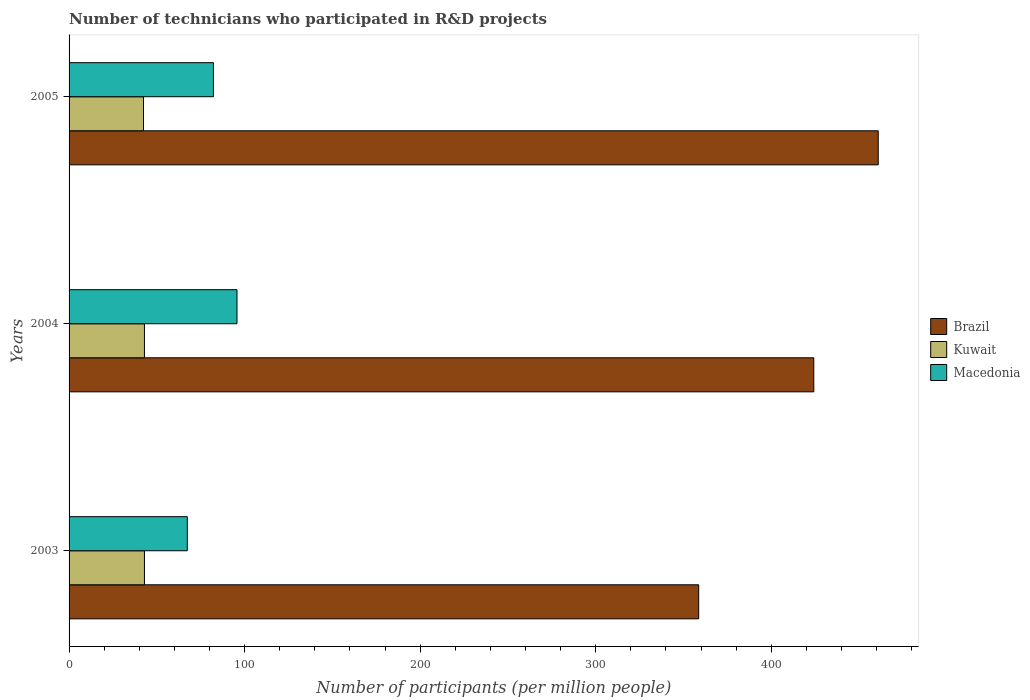How many different coloured bars are there?
Provide a short and direct response. 3. How many groups of bars are there?
Keep it short and to the point. 3. Are the number of bars per tick equal to the number of legend labels?
Offer a terse response. Yes. Are the number of bars on each tick of the Y-axis equal?
Provide a succinct answer. Yes. How many bars are there on the 1st tick from the bottom?
Make the answer very short. 3. What is the number of technicians who participated in R&D projects in Macedonia in 2005?
Your answer should be compact. 82.24. Across all years, what is the maximum number of technicians who participated in R&D projects in Macedonia?
Provide a short and direct response. 95.66. Across all years, what is the minimum number of technicians who participated in R&D projects in Kuwait?
Make the answer very short. 42.41. What is the total number of technicians who participated in R&D projects in Brazil in the graph?
Provide a succinct answer. 1243.77. What is the difference between the number of technicians who participated in R&D projects in Macedonia in 2003 and that in 2004?
Give a very brief answer. -28.31. What is the difference between the number of technicians who participated in R&D projects in Brazil in 2004 and the number of technicians who participated in R&D projects in Macedonia in 2005?
Offer a terse response. 341.98. What is the average number of technicians who participated in R&D projects in Macedonia per year?
Give a very brief answer. 81.75. In the year 2003, what is the difference between the number of technicians who participated in R&D projects in Kuwait and number of technicians who participated in R&D projects in Brazil?
Your response must be concise. -315.71. In how many years, is the number of technicians who participated in R&D projects in Kuwait greater than 200 ?
Make the answer very short. 0. What is the ratio of the number of technicians who participated in R&D projects in Kuwait in 2003 to that in 2005?
Ensure brevity in your answer.  1.01. What is the difference between the highest and the second highest number of technicians who participated in R&D projects in Kuwait?
Ensure brevity in your answer.  0.01. What is the difference between the highest and the lowest number of technicians who participated in R&D projects in Kuwait?
Your response must be concise. 0.53. In how many years, is the number of technicians who participated in R&D projects in Brazil greater than the average number of technicians who participated in R&D projects in Brazil taken over all years?
Your answer should be very brief. 2. What does the 1st bar from the top in 2005 represents?
Offer a very short reply. Macedonia. What does the 2nd bar from the bottom in 2003 represents?
Give a very brief answer. Kuwait. What is the difference between two consecutive major ticks on the X-axis?
Make the answer very short. 100. Are the values on the major ticks of X-axis written in scientific E-notation?
Offer a terse response. No. Does the graph contain any zero values?
Your response must be concise. No. Where does the legend appear in the graph?
Ensure brevity in your answer.  Center right. What is the title of the graph?
Offer a very short reply. Number of technicians who participated in R&D projects. What is the label or title of the X-axis?
Your response must be concise. Number of participants (per million people). What is the label or title of the Y-axis?
Offer a terse response. Years. What is the Number of participants (per million people) in Brazil in 2003?
Offer a very short reply. 358.64. What is the Number of participants (per million people) in Kuwait in 2003?
Give a very brief answer. 42.94. What is the Number of participants (per million people) of Macedonia in 2003?
Provide a succinct answer. 67.36. What is the Number of participants (per million people) of Brazil in 2004?
Offer a very short reply. 424.21. What is the Number of participants (per million people) of Kuwait in 2004?
Offer a very short reply. 42.93. What is the Number of participants (per million people) in Macedonia in 2004?
Your response must be concise. 95.66. What is the Number of participants (per million people) of Brazil in 2005?
Keep it short and to the point. 460.92. What is the Number of participants (per million people) of Kuwait in 2005?
Provide a short and direct response. 42.41. What is the Number of participants (per million people) of Macedonia in 2005?
Offer a very short reply. 82.24. Across all years, what is the maximum Number of participants (per million people) of Brazil?
Make the answer very short. 460.92. Across all years, what is the maximum Number of participants (per million people) in Kuwait?
Keep it short and to the point. 42.94. Across all years, what is the maximum Number of participants (per million people) in Macedonia?
Provide a succinct answer. 95.66. Across all years, what is the minimum Number of participants (per million people) of Brazil?
Make the answer very short. 358.64. Across all years, what is the minimum Number of participants (per million people) of Kuwait?
Keep it short and to the point. 42.41. Across all years, what is the minimum Number of participants (per million people) in Macedonia?
Your answer should be compact. 67.36. What is the total Number of participants (per million people) of Brazil in the graph?
Offer a very short reply. 1243.77. What is the total Number of participants (per million people) in Kuwait in the graph?
Keep it short and to the point. 128.28. What is the total Number of participants (per million people) in Macedonia in the graph?
Ensure brevity in your answer.  245.25. What is the difference between the Number of participants (per million people) in Brazil in 2003 and that in 2004?
Give a very brief answer. -65.57. What is the difference between the Number of participants (per million people) of Kuwait in 2003 and that in 2004?
Provide a short and direct response. 0.01. What is the difference between the Number of participants (per million people) in Macedonia in 2003 and that in 2004?
Provide a succinct answer. -28.31. What is the difference between the Number of participants (per million people) in Brazil in 2003 and that in 2005?
Your answer should be compact. -102.27. What is the difference between the Number of participants (per million people) in Kuwait in 2003 and that in 2005?
Provide a short and direct response. 0.53. What is the difference between the Number of participants (per million people) in Macedonia in 2003 and that in 2005?
Make the answer very short. -14.88. What is the difference between the Number of participants (per million people) in Brazil in 2004 and that in 2005?
Your answer should be very brief. -36.7. What is the difference between the Number of participants (per million people) in Kuwait in 2004 and that in 2005?
Offer a terse response. 0.52. What is the difference between the Number of participants (per million people) of Macedonia in 2004 and that in 2005?
Provide a succinct answer. 13.42. What is the difference between the Number of participants (per million people) of Brazil in 2003 and the Number of participants (per million people) of Kuwait in 2004?
Make the answer very short. 315.72. What is the difference between the Number of participants (per million people) in Brazil in 2003 and the Number of participants (per million people) in Macedonia in 2004?
Ensure brevity in your answer.  262.98. What is the difference between the Number of participants (per million people) of Kuwait in 2003 and the Number of participants (per million people) of Macedonia in 2004?
Your response must be concise. -52.72. What is the difference between the Number of participants (per million people) in Brazil in 2003 and the Number of participants (per million people) in Kuwait in 2005?
Offer a terse response. 316.23. What is the difference between the Number of participants (per million people) of Brazil in 2003 and the Number of participants (per million people) of Macedonia in 2005?
Your answer should be very brief. 276.41. What is the difference between the Number of participants (per million people) of Kuwait in 2003 and the Number of participants (per million people) of Macedonia in 2005?
Offer a terse response. -39.3. What is the difference between the Number of participants (per million people) of Brazil in 2004 and the Number of participants (per million people) of Kuwait in 2005?
Provide a succinct answer. 381.8. What is the difference between the Number of participants (per million people) in Brazil in 2004 and the Number of participants (per million people) in Macedonia in 2005?
Your answer should be compact. 341.98. What is the difference between the Number of participants (per million people) of Kuwait in 2004 and the Number of participants (per million people) of Macedonia in 2005?
Provide a short and direct response. -39.31. What is the average Number of participants (per million people) of Brazil per year?
Your answer should be very brief. 414.59. What is the average Number of participants (per million people) of Kuwait per year?
Give a very brief answer. 42.76. What is the average Number of participants (per million people) in Macedonia per year?
Make the answer very short. 81.75. In the year 2003, what is the difference between the Number of participants (per million people) of Brazil and Number of participants (per million people) of Kuwait?
Provide a succinct answer. 315.71. In the year 2003, what is the difference between the Number of participants (per million people) in Brazil and Number of participants (per million people) in Macedonia?
Your response must be concise. 291.29. In the year 2003, what is the difference between the Number of participants (per million people) in Kuwait and Number of participants (per million people) in Macedonia?
Offer a very short reply. -24.42. In the year 2004, what is the difference between the Number of participants (per million people) in Brazil and Number of participants (per million people) in Kuwait?
Your response must be concise. 381.28. In the year 2004, what is the difference between the Number of participants (per million people) of Brazil and Number of participants (per million people) of Macedonia?
Your response must be concise. 328.55. In the year 2004, what is the difference between the Number of participants (per million people) in Kuwait and Number of participants (per million people) in Macedonia?
Your answer should be compact. -52.73. In the year 2005, what is the difference between the Number of participants (per million people) in Brazil and Number of participants (per million people) in Kuwait?
Your answer should be compact. 418.51. In the year 2005, what is the difference between the Number of participants (per million people) in Brazil and Number of participants (per million people) in Macedonia?
Ensure brevity in your answer.  378.68. In the year 2005, what is the difference between the Number of participants (per million people) in Kuwait and Number of participants (per million people) in Macedonia?
Give a very brief answer. -39.83. What is the ratio of the Number of participants (per million people) of Brazil in 2003 to that in 2004?
Keep it short and to the point. 0.85. What is the ratio of the Number of participants (per million people) in Kuwait in 2003 to that in 2004?
Your answer should be compact. 1. What is the ratio of the Number of participants (per million people) of Macedonia in 2003 to that in 2004?
Provide a succinct answer. 0.7. What is the ratio of the Number of participants (per million people) of Brazil in 2003 to that in 2005?
Offer a terse response. 0.78. What is the ratio of the Number of participants (per million people) in Kuwait in 2003 to that in 2005?
Offer a very short reply. 1.01. What is the ratio of the Number of participants (per million people) in Macedonia in 2003 to that in 2005?
Offer a very short reply. 0.82. What is the ratio of the Number of participants (per million people) of Brazil in 2004 to that in 2005?
Your answer should be compact. 0.92. What is the ratio of the Number of participants (per million people) of Kuwait in 2004 to that in 2005?
Your answer should be very brief. 1.01. What is the ratio of the Number of participants (per million people) of Macedonia in 2004 to that in 2005?
Your answer should be very brief. 1.16. What is the difference between the highest and the second highest Number of participants (per million people) in Brazil?
Provide a short and direct response. 36.7. What is the difference between the highest and the second highest Number of participants (per million people) in Kuwait?
Keep it short and to the point. 0.01. What is the difference between the highest and the second highest Number of participants (per million people) in Macedonia?
Offer a very short reply. 13.42. What is the difference between the highest and the lowest Number of participants (per million people) of Brazil?
Keep it short and to the point. 102.27. What is the difference between the highest and the lowest Number of participants (per million people) in Kuwait?
Offer a terse response. 0.53. What is the difference between the highest and the lowest Number of participants (per million people) of Macedonia?
Make the answer very short. 28.31. 